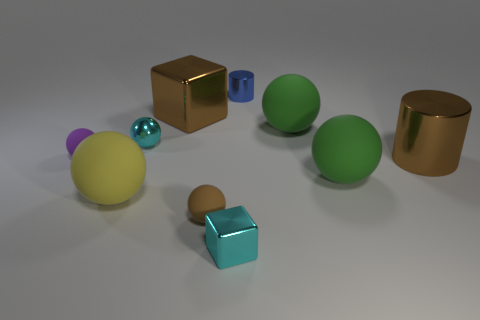Subtract all big green balls. How many balls are left? 4 Add 7 yellow things. How many yellow things are left? 8 Add 5 big green balls. How many big green balls exist? 7 Subtract all blue cylinders. How many cylinders are left? 1 Subtract 1 brown cylinders. How many objects are left? 9 Subtract all blocks. How many objects are left? 8 Subtract 2 cylinders. How many cylinders are left? 0 Subtract all green cubes. Subtract all blue cylinders. How many cubes are left? 2 Subtract all purple balls. How many brown cylinders are left? 1 Subtract all purple matte things. Subtract all tiny cylinders. How many objects are left? 8 